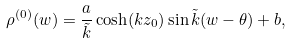Convert formula to latex. <formula><loc_0><loc_0><loc_500><loc_500>\rho ^ { ( 0 ) } ( w ) = \frac { a } { \tilde { k } } \cosh ( k z _ { 0 } ) \sin \tilde { k } ( w - \theta ) + b ,</formula> 